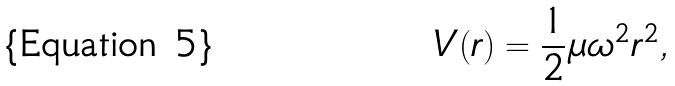Convert formula to latex. <formula><loc_0><loc_0><loc_500><loc_500>V ( r ) = { \frac { 1 } { 2 } } \mu \omega ^ { 2 } r ^ { 2 } ,</formula> 